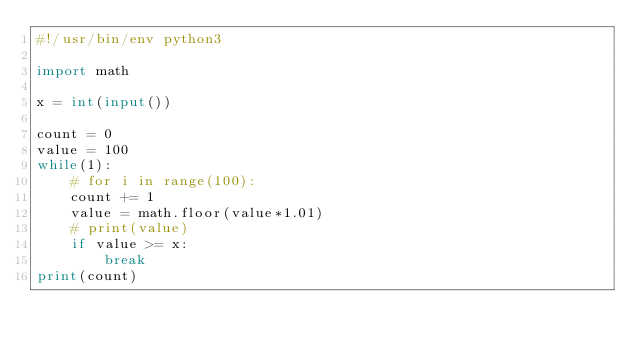<code> <loc_0><loc_0><loc_500><loc_500><_Python_>#!/usr/bin/env python3

import math

x = int(input())

count = 0
value = 100
while(1):
    # for i in range(100):
    count += 1
    value = math.floor(value*1.01)
    # print(value)
    if value >= x:
        break
print(count)
</code> 